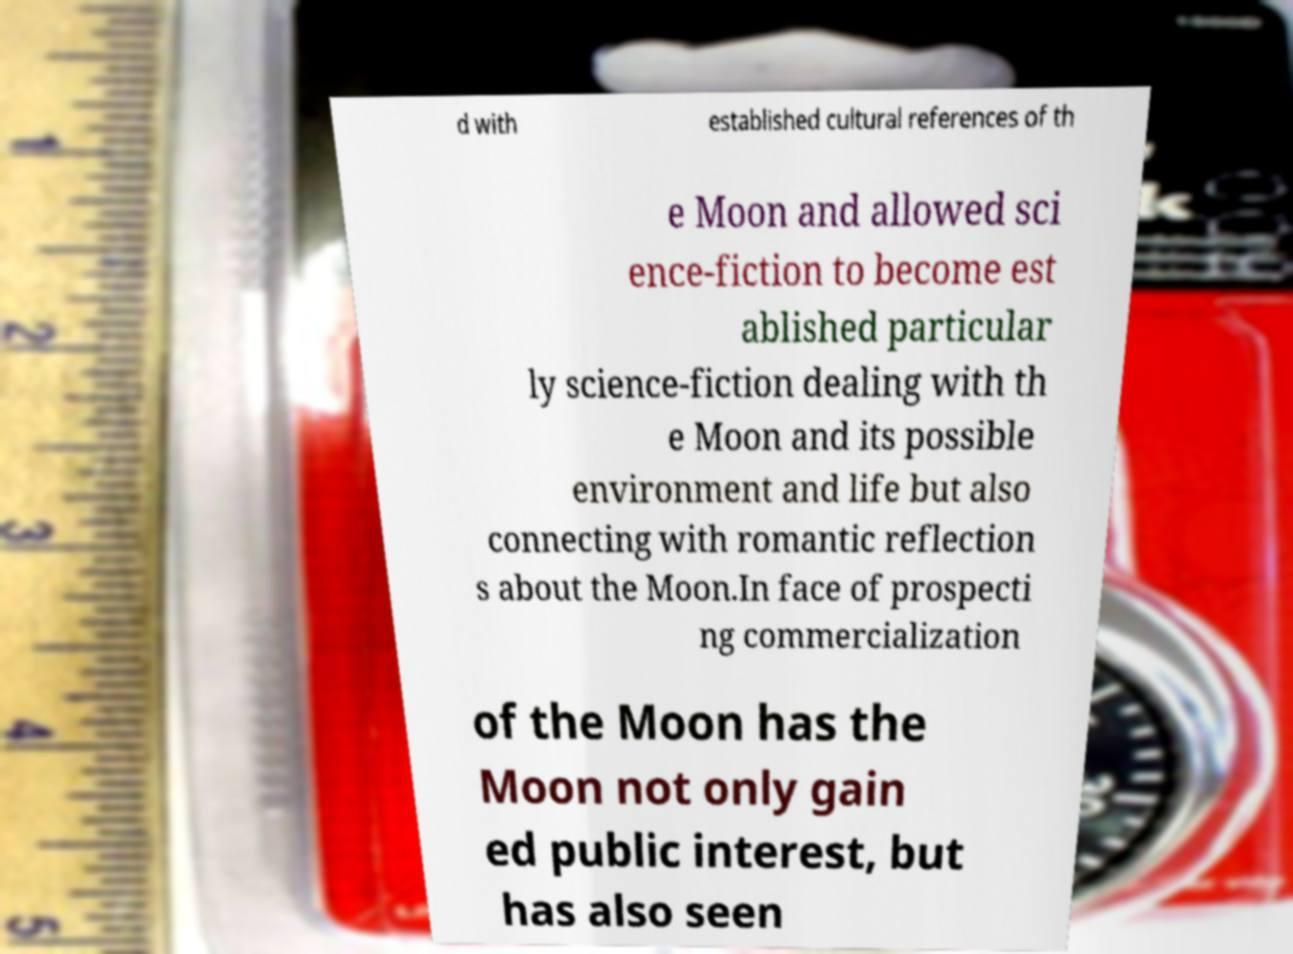There's text embedded in this image that I need extracted. Can you transcribe it verbatim? d with established cultural references of th e Moon and allowed sci ence-fiction to become est ablished particular ly science-fiction dealing with th e Moon and its possible environment and life but also connecting with romantic reflection s about the Moon.In face of prospecti ng commercialization of the Moon has the Moon not only gain ed public interest, but has also seen 